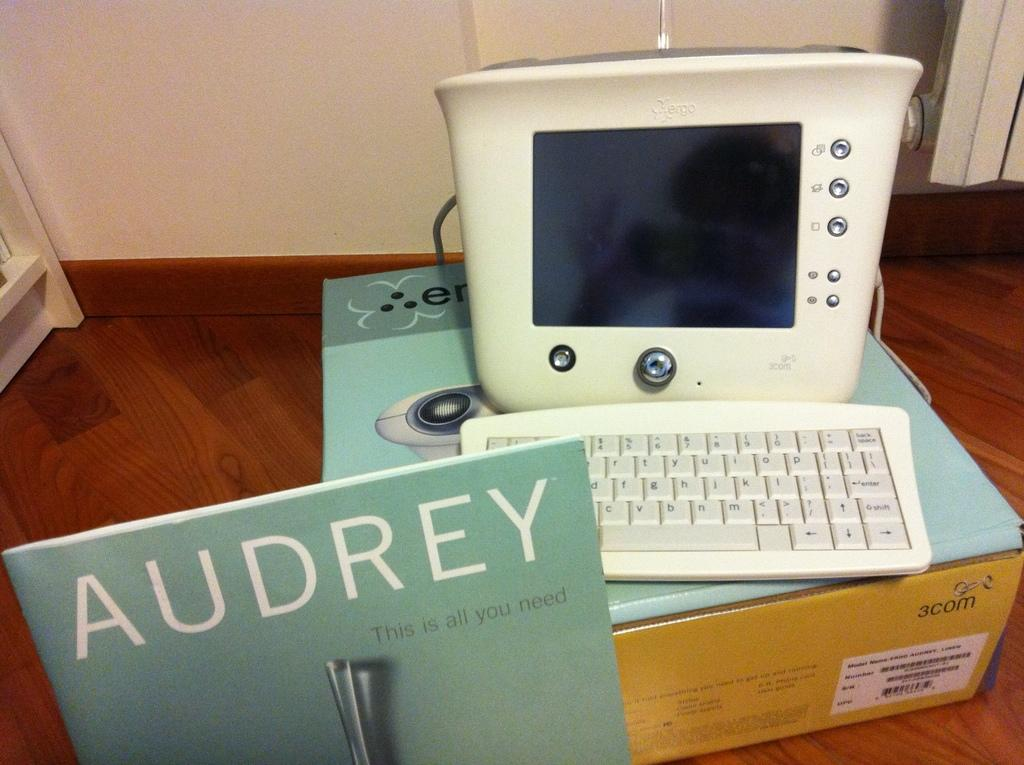Provide a one-sentence caption for the provided image. A book that says 'Audrey" on it in front of a computer. 